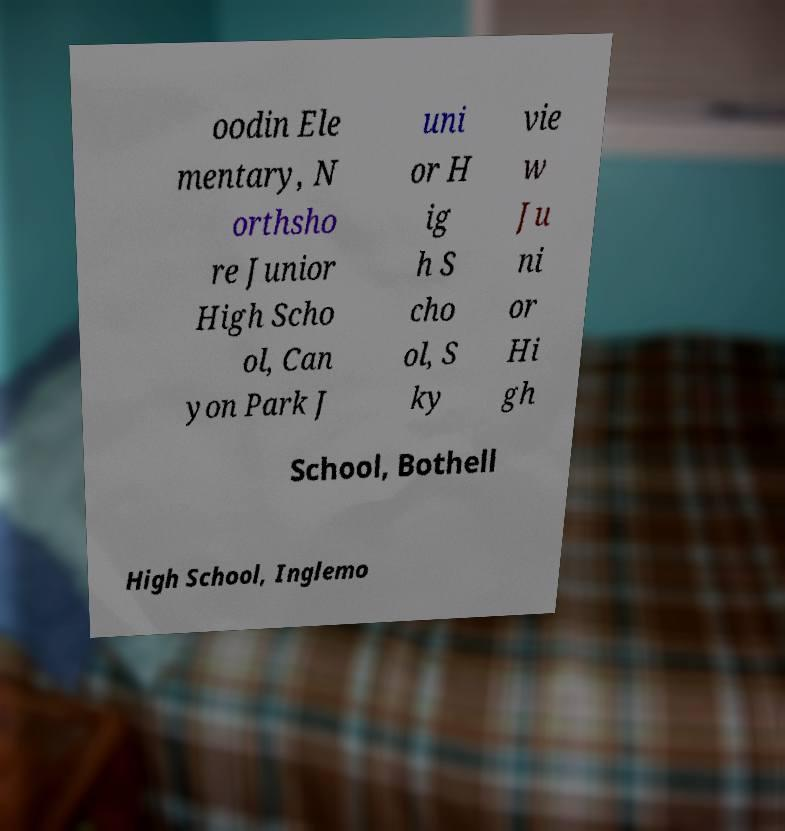There's text embedded in this image that I need extracted. Can you transcribe it verbatim? oodin Ele mentary, N orthsho re Junior High Scho ol, Can yon Park J uni or H ig h S cho ol, S ky vie w Ju ni or Hi gh School, Bothell High School, Inglemo 